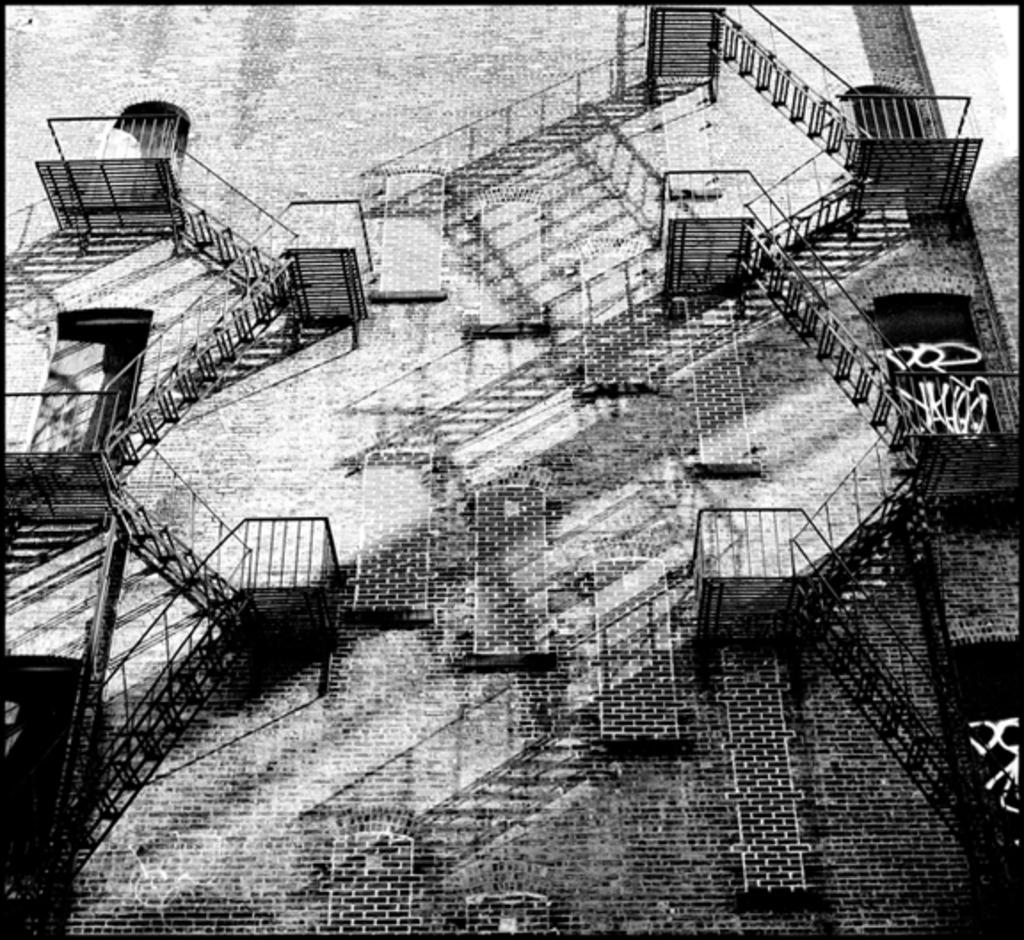What is the main subject of the image? The main subject of the image is an outer view of a building. Can you describe any unique features of the building? Yes, there are stairs in the shape of ladders connecting different floors of the building. What type of stone is used to build the bird's nest on the top floor of the building? There is no bird's nest or any mention of stone in the image or the provided facts. 